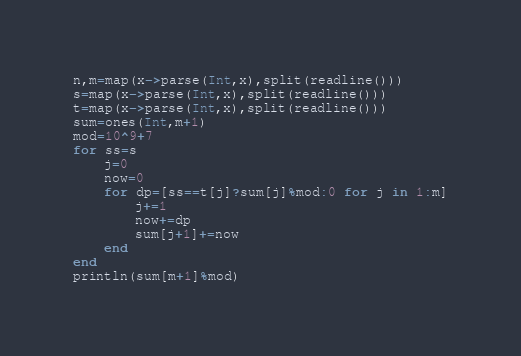<code> <loc_0><loc_0><loc_500><loc_500><_Julia_>n,m=map(x->parse(Int,x),split(readline()))
s=map(x->parse(Int,x),split(readline()))
t=map(x->parse(Int,x),split(readline()))
sum=ones(Int,m+1)
mod=10^9+7
for ss=s
	j=0
	now=0
	for dp=[ss==t[j]?sum[j]%mod:0 for j in 1:m]
		j+=1
		now+=dp
		sum[j+1]+=now
	end
end
println(sum[m+1]%mod)</code> 